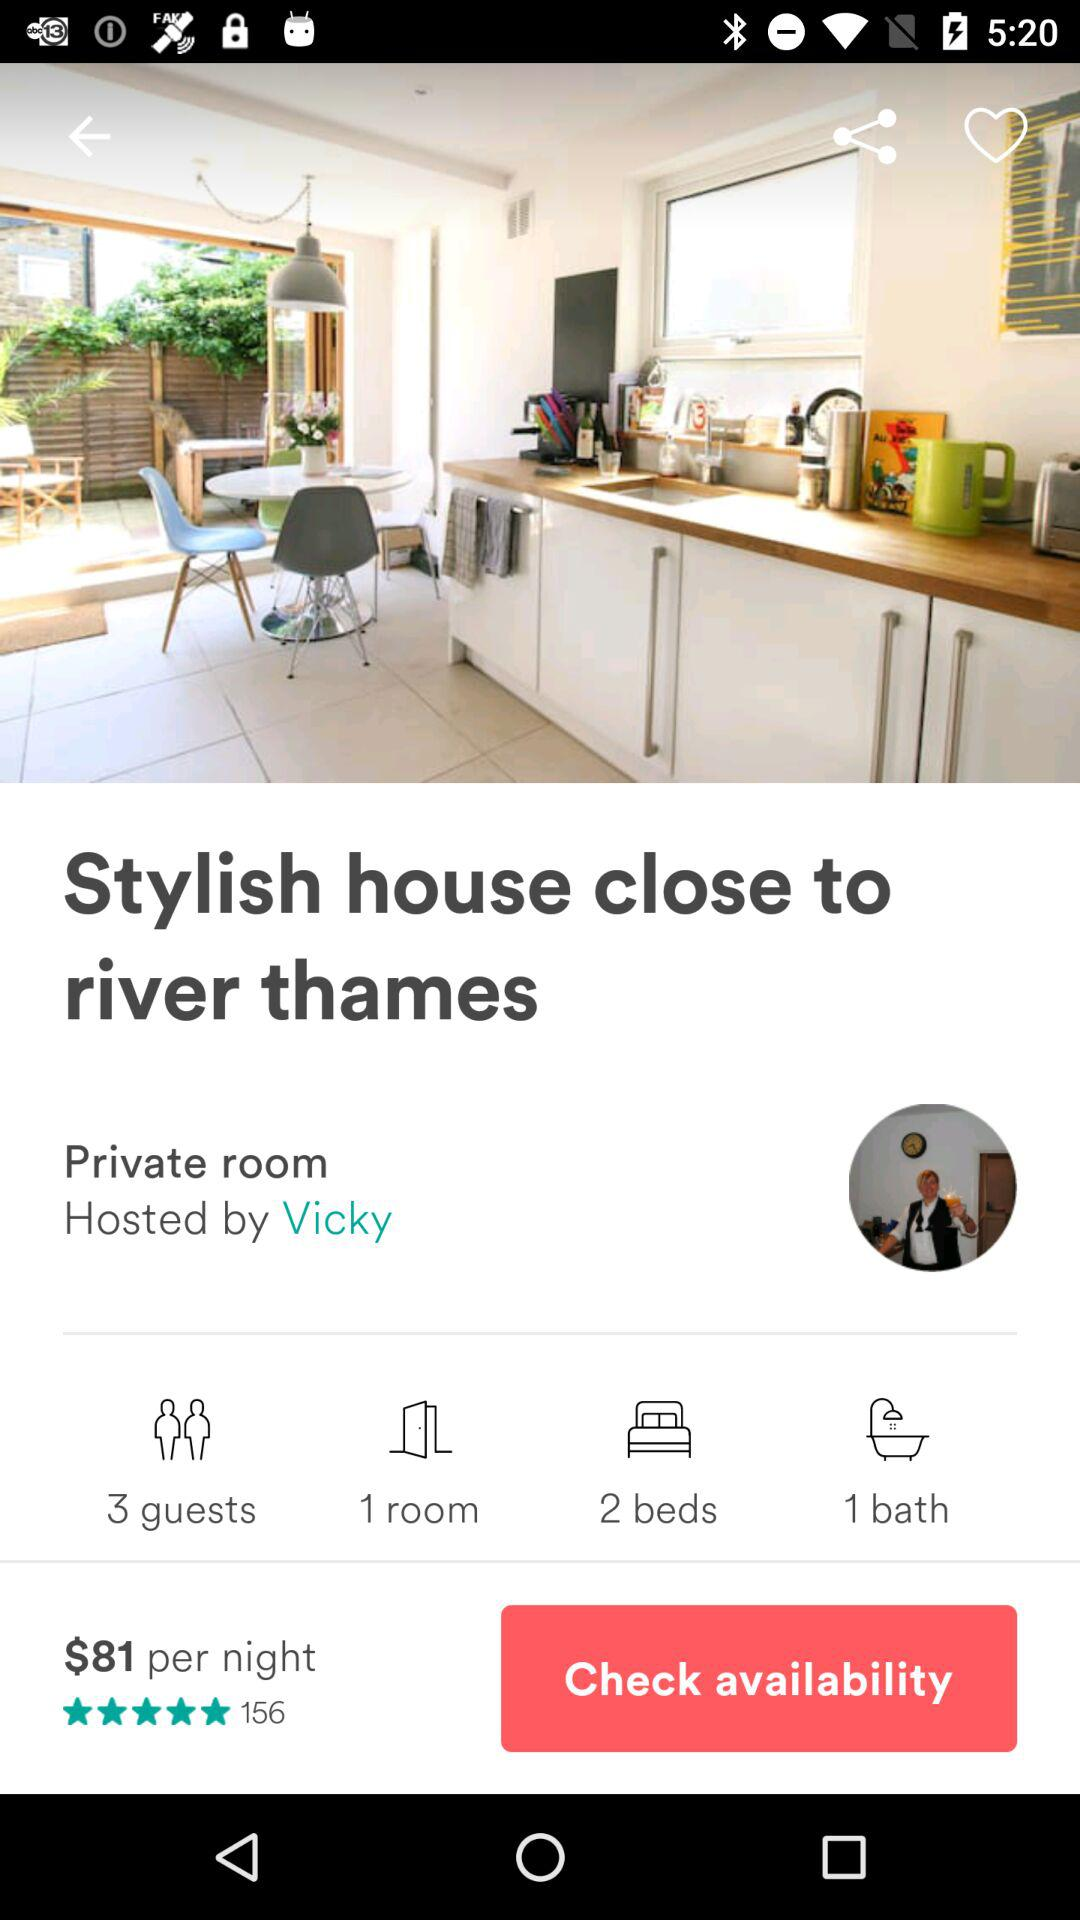How many rooms are selected for booking? The selected room for booking is 1. 